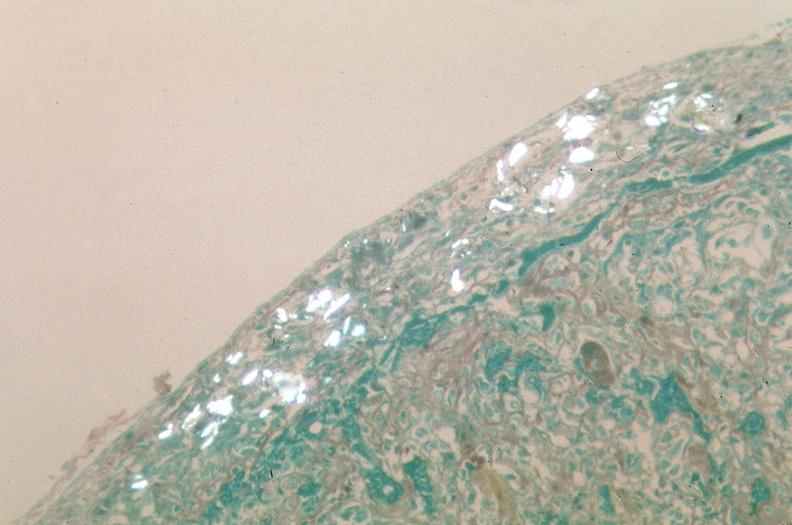does sac show pleura, talc reaction showing talc birefringence?
Answer the question using a single word or phrase. No 